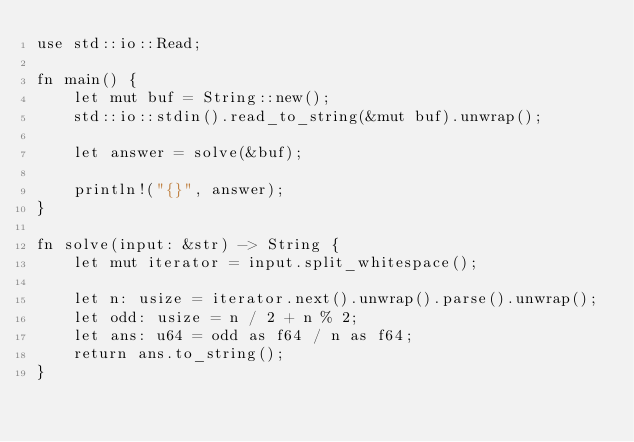<code> <loc_0><loc_0><loc_500><loc_500><_Rust_>use std::io::Read;

fn main() {
    let mut buf = String::new();
    std::io::stdin().read_to_string(&mut buf).unwrap();

    let answer = solve(&buf);

    println!("{}", answer);
}

fn solve(input: &str) -> String {
    let mut iterator = input.split_whitespace();

    let n: usize = iterator.next().unwrap().parse().unwrap();
    let odd: usize = n / 2 + n % 2;
    let ans: u64 = odd as f64 / n as f64;
    return ans.to_string();
}</code> 